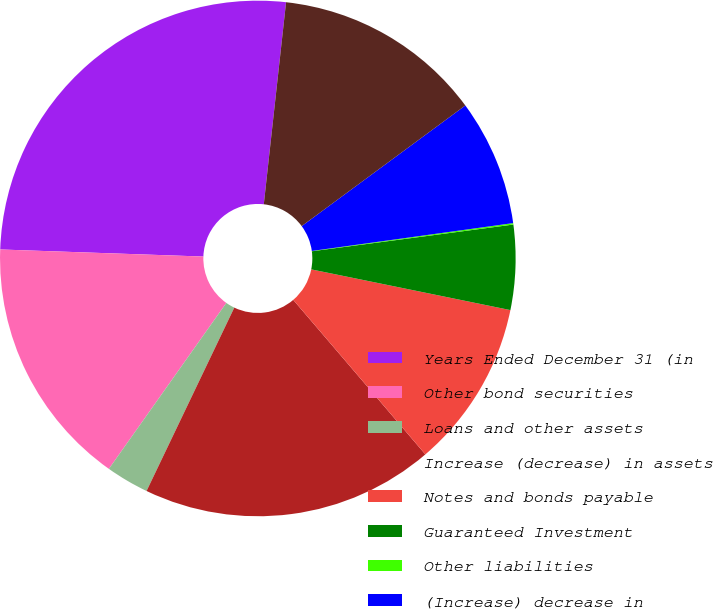<chart> <loc_0><loc_0><loc_500><loc_500><pie_chart><fcel>Years Ended December 31 (in<fcel>Other bond securities<fcel>Loans and other assets<fcel>Increase (decrease) in assets<fcel>Notes and bonds payable<fcel>Guaranteed Investment<fcel>Other liabilities<fcel>(Increase) decrease in<fcel>Net increase to pre-tax<nl><fcel>26.19%<fcel>15.75%<fcel>2.7%<fcel>18.36%<fcel>10.53%<fcel>5.31%<fcel>0.09%<fcel>7.92%<fcel>13.14%<nl></chart> 